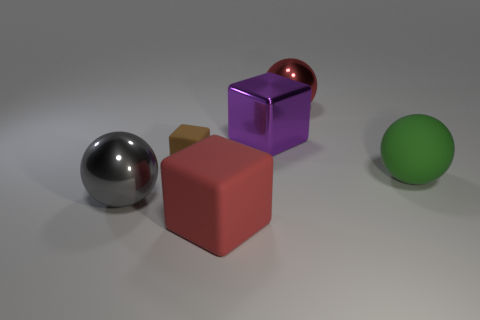Subtract all large metal balls. How many balls are left? 1 Add 4 spheres. How many objects exist? 10 Subtract all cyan things. Subtract all large rubber cubes. How many objects are left? 5 Add 4 small brown rubber blocks. How many small brown rubber blocks are left? 5 Add 1 large blue metal blocks. How many large blue metal blocks exist? 1 Subtract 1 gray spheres. How many objects are left? 5 